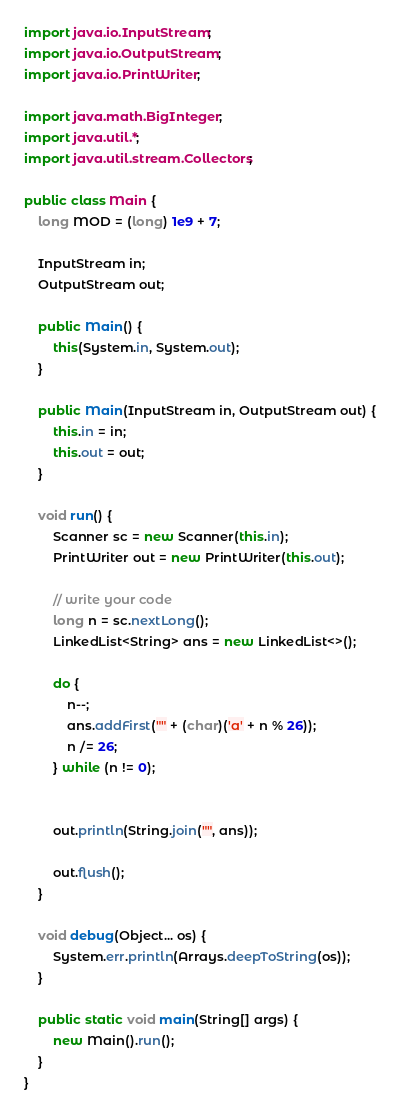<code> <loc_0><loc_0><loc_500><loc_500><_Java_>
import java.io.InputStream;
import java.io.OutputStream;
import java.io.PrintWriter;

import java.math.BigInteger;
import java.util.*;
import java.util.stream.Collectors;

public class Main {
    long MOD = (long) 1e9 + 7;

    InputStream in;
    OutputStream out;

    public Main() {
        this(System.in, System.out);
    }

    public Main(InputStream in, OutputStream out) {
        this.in = in;
        this.out = out;
    }

    void run() {
        Scanner sc = new Scanner(this.in);
        PrintWriter out = new PrintWriter(this.out);

        // write your code
        long n = sc.nextLong();
        LinkedList<String> ans = new LinkedList<>();

        do {
            n--;
            ans.addFirst("" + (char)('a' + n % 26));
            n /= 26;
        } while (n != 0);


        out.println(String.join("", ans));

        out.flush();
    }

    void debug(Object... os) {
        System.err.println(Arrays.deepToString(os));
    }

    public static void main(String[] args) {
        new Main().run();
    }
}</code> 